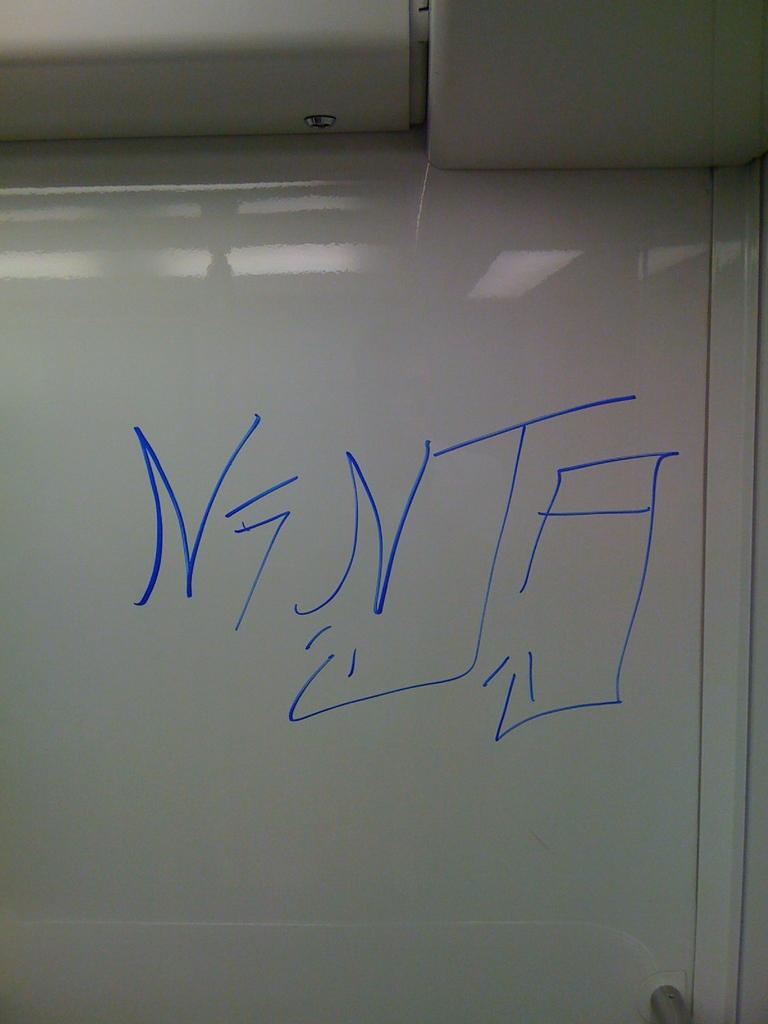<image>
Present a compact description of the photo's key features. Someone has written "NTA" on a whiteboard in blue marker. 